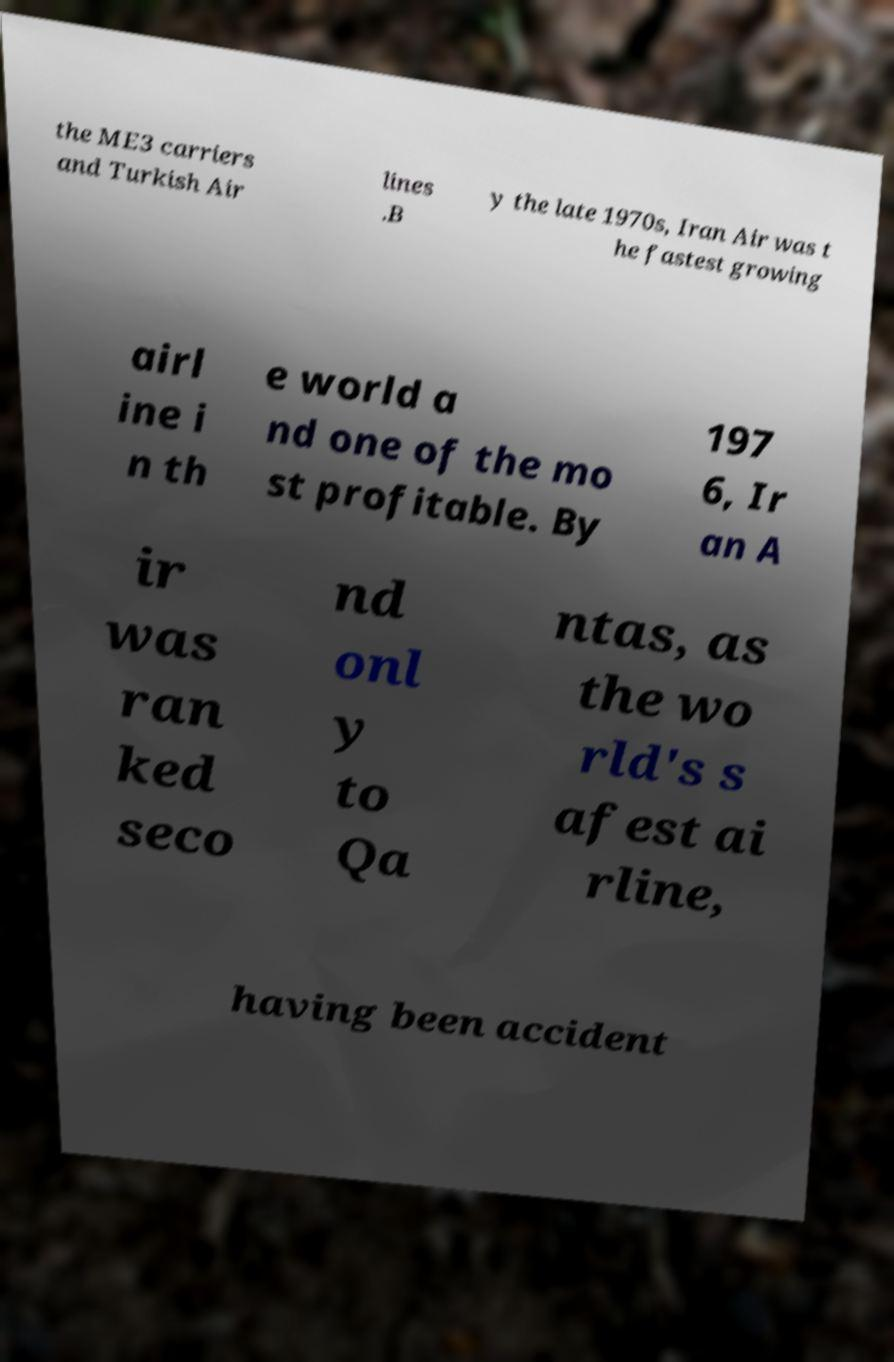For documentation purposes, I need the text within this image transcribed. Could you provide that? the ME3 carriers and Turkish Air lines .B y the late 1970s, Iran Air was t he fastest growing airl ine i n th e world a nd one of the mo st profitable. By 197 6, Ir an A ir was ran ked seco nd onl y to Qa ntas, as the wo rld's s afest ai rline, having been accident 